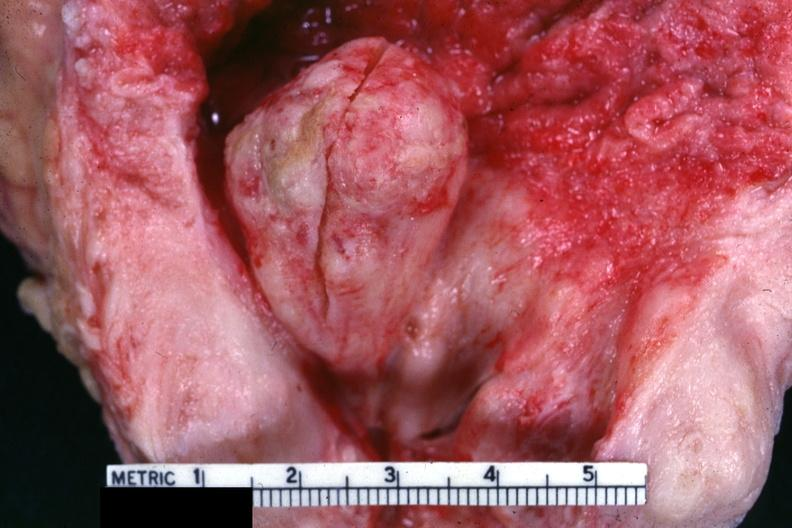what does this image show?
Answer the question using a single word or phrase. Good example of nodule protruding into bladder 